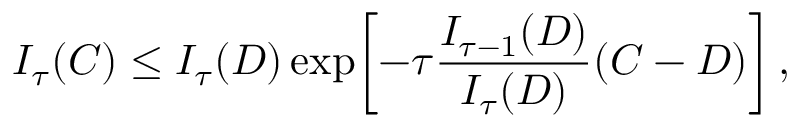Convert formula to latex. <formula><loc_0><loc_0><loc_500><loc_500>I _ { \tau } ( C ) \leq I _ { \tau } ( D ) \exp \, \left [ - \tau { \frac { I _ { \tau - 1 } ( D ) } { I _ { \tau } ( D ) } } ( C - D ) \right ] ,</formula> 